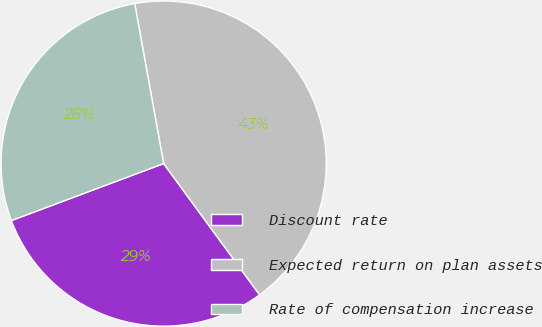<chart> <loc_0><loc_0><loc_500><loc_500><pie_chart><fcel>Discount rate<fcel>Expected return on plan assets<fcel>Rate of compensation increase<nl><fcel>29.35%<fcel>42.8%<fcel>27.85%<nl></chart> 